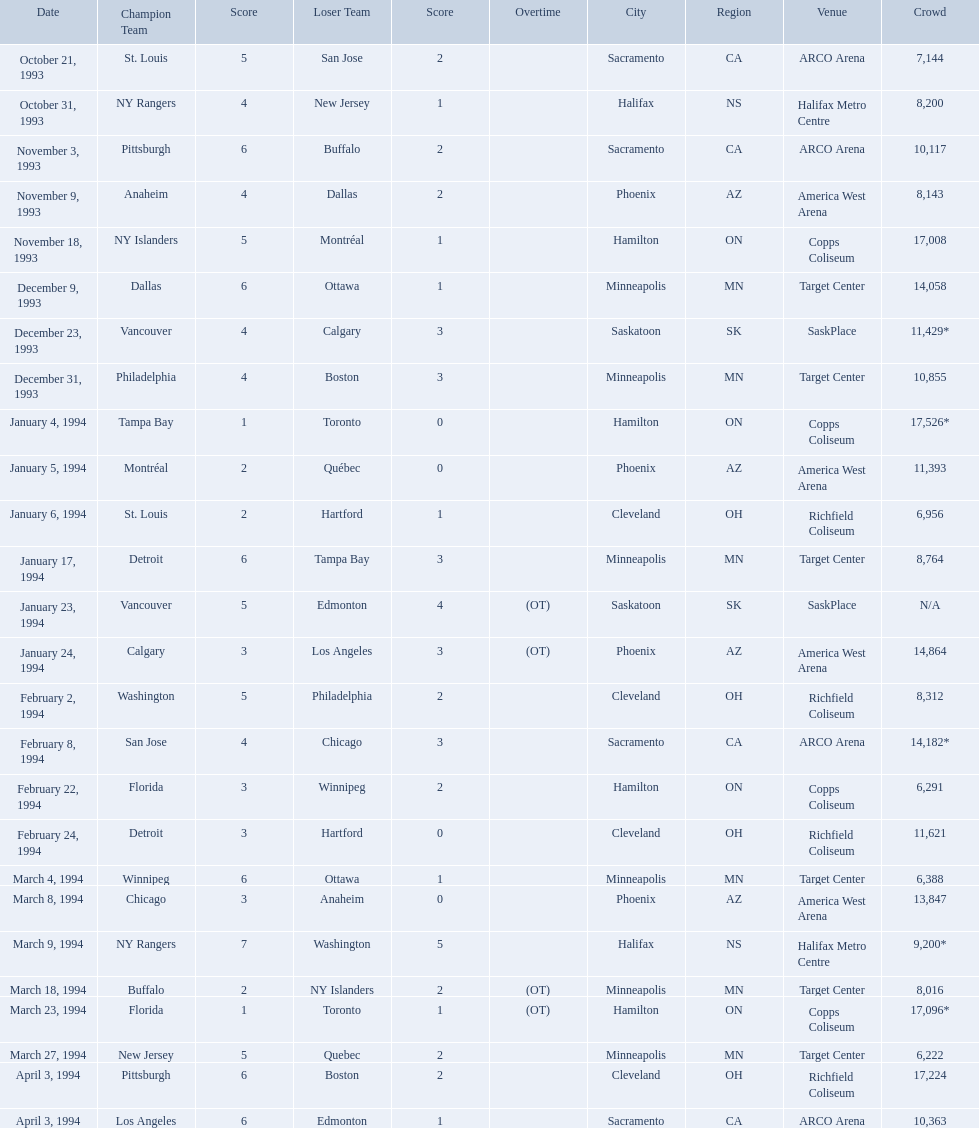Which dates saw the winning team score only one point? January 4, 1994, March 23, 1994. Of these two, which date had higher attendance? January 4, 1994. On which dates were all the games? October 21, 1993, October 31, 1993, November 3, 1993, November 9, 1993, November 18, 1993, December 9, 1993, December 23, 1993, December 31, 1993, January 4, 1994, January 5, 1994, January 6, 1994, January 17, 1994, January 23, 1994, January 24, 1994, February 2, 1994, February 8, 1994, February 22, 1994, February 24, 1994, March 4, 1994, March 8, 1994, March 9, 1994, March 18, 1994, March 23, 1994, March 27, 1994, April 3, 1994, April 3, 1994. What were the attendances? 7,144, 8,200, 10,117, 8,143, 17,008, 14,058, 11,429*, 10,855, 17,526*, 11,393, 6,956, 8,764, N/A, 14,864, 8,312, 14,182*, 6,291, 11,621, 6,388, 13,847, 9,200*, 8,016, 17,096*, 6,222, 17,224, 10,363. And between december 23, 1993 and january 24, 1994, which game had the highest turnout? January 4, 1994. Which was the highest attendance for a game? 17,526*. What was the date of the game with an attendance of 17,526? January 4, 1994. Would you be able to parse every entry in this table? {'header': ['Date', 'Champion Team', 'Score', 'Loser Team', 'Score', 'Overtime', 'City', 'Region', 'Venue', 'Crowd'], 'rows': [['October 21, 1993', 'St. Louis', '5', 'San Jose', '2', '', 'Sacramento', 'CA', 'ARCO Arena', '7,144'], ['October 31, 1993', 'NY Rangers', '4', 'New Jersey', '1', '', 'Halifax', 'NS', 'Halifax Metro Centre', '8,200'], ['November 3, 1993', 'Pittsburgh', '6', 'Buffalo', '2', '', 'Sacramento', 'CA', 'ARCO Arena', '10,117'], ['November 9, 1993', 'Anaheim', '4', 'Dallas', '2', '', 'Phoenix', 'AZ', 'America West Arena', '8,143'], ['November 18, 1993', 'NY Islanders', '5', 'Montréal', '1', '', 'Hamilton', 'ON', 'Copps Coliseum', '17,008'], ['December 9, 1993', 'Dallas', '6', 'Ottawa', '1', '', 'Minneapolis', 'MN', 'Target Center', '14,058'], ['December 23, 1993', 'Vancouver', '4', 'Calgary', '3', '', 'Saskatoon', 'SK', 'SaskPlace', '11,429*'], ['December 31, 1993', 'Philadelphia', '4', 'Boston', '3', '', 'Minneapolis', 'MN', 'Target Center', '10,855'], ['January 4, 1994', 'Tampa Bay', '1', 'Toronto', '0', '', 'Hamilton', 'ON', 'Copps Coliseum', '17,526*'], ['January 5, 1994', 'Montréal', '2', 'Québec', '0', '', 'Phoenix', 'AZ', 'America West Arena', '11,393'], ['January 6, 1994', 'St. Louis', '2', 'Hartford', '1', '', 'Cleveland', 'OH', 'Richfield Coliseum', '6,956'], ['January 17, 1994', 'Detroit', '6', 'Tampa Bay', '3', '', 'Minneapolis', 'MN', 'Target Center', '8,764'], ['January 23, 1994', 'Vancouver', '5', 'Edmonton', '4', '(OT)', 'Saskatoon', 'SK', 'SaskPlace', 'N/A'], ['January 24, 1994', 'Calgary', '3', 'Los Angeles', '3', '(OT)', 'Phoenix', 'AZ', 'America West Arena', '14,864'], ['February 2, 1994', 'Washington', '5', 'Philadelphia', '2', '', 'Cleveland', 'OH', 'Richfield Coliseum', '8,312'], ['February 8, 1994', 'San Jose', '4', 'Chicago', '3', '', 'Sacramento', 'CA', 'ARCO Arena', '14,182*'], ['February 22, 1994', 'Florida', '3', 'Winnipeg', '2', '', 'Hamilton', 'ON', 'Copps Coliseum', '6,291'], ['February 24, 1994', 'Detroit', '3', 'Hartford', '0', '', 'Cleveland', 'OH', 'Richfield Coliseum', '11,621'], ['March 4, 1994', 'Winnipeg', '6', 'Ottawa', '1', '', 'Minneapolis', 'MN', 'Target Center', '6,388'], ['March 8, 1994', 'Chicago', '3', 'Anaheim', '0', '', 'Phoenix', 'AZ', 'America West Arena', '13,847'], ['March 9, 1994', 'NY Rangers', '7', 'Washington', '5', '', 'Halifax', 'NS', 'Halifax Metro Centre', '9,200*'], ['March 18, 1994', 'Buffalo', '2', 'NY Islanders', '2', '(OT)', 'Minneapolis', 'MN', 'Target Center', '8,016'], ['March 23, 1994', 'Florida', '1', 'Toronto', '1', '(OT)', 'Hamilton', 'ON', 'Copps Coliseum', '17,096*'], ['March 27, 1994', 'New Jersey', '5', 'Quebec', '2', '', 'Minneapolis', 'MN', 'Target Center', '6,222'], ['April 3, 1994', 'Pittsburgh', '6', 'Boston', '2', '', 'Cleveland', 'OH', 'Richfield Coliseum', '17,224'], ['April 3, 1994', 'Los Angeles', '6', 'Edmonton', '1', '', 'Sacramento', 'CA', 'ARCO Arena', '10,363']]} What are the attendances of the 1993-94 nhl season? 7,144, 8,200, 10,117, 8,143, 17,008, 14,058, 11,429*, 10,855, 17,526*, 11,393, 6,956, 8,764, N/A, 14,864, 8,312, 14,182*, 6,291, 11,621, 6,388, 13,847, 9,200*, 8,016, 17,096*, 6,222, 17,224, 10,363. Which of these is the highest attendance? 17,526*. Which date did this attendance occur? January 4, 1994. When were the games played? October 21, 1993, October 31, 1993, November 3, 1993, November 9, 1993, November 18, 1993, December 9, 1993, December 23, 1993, December 31, 1993, January 4, 1994, January 5, 1994, January 6, 1994, January 17, 1994, January 23, 1994, January 24, 1994, February 2, 1994, February 8, 1994, February 22, 1994, February 24, 1994, March 4, 1994, March 8, 1994, March 9, 1994, March 18, 1994, March 23, 1994, March 27, 1994, April 3, 1994, April 3, 1994. What was the attendance for those games? 7,144, 8,200, 10,117, 8,143, 17,008, 14,058, 11,429*, 10,855, 17,526*, 11,393, 6,956, 8,764, N/A, 14,864, 8,312, 14,182*, 6,291, 11,621, 6,388, 13,847, 9,200*, 8,016, 17,096*, 6,222, 17,224, 10,363. Which date had the highest attendance? January 4, 1994. 